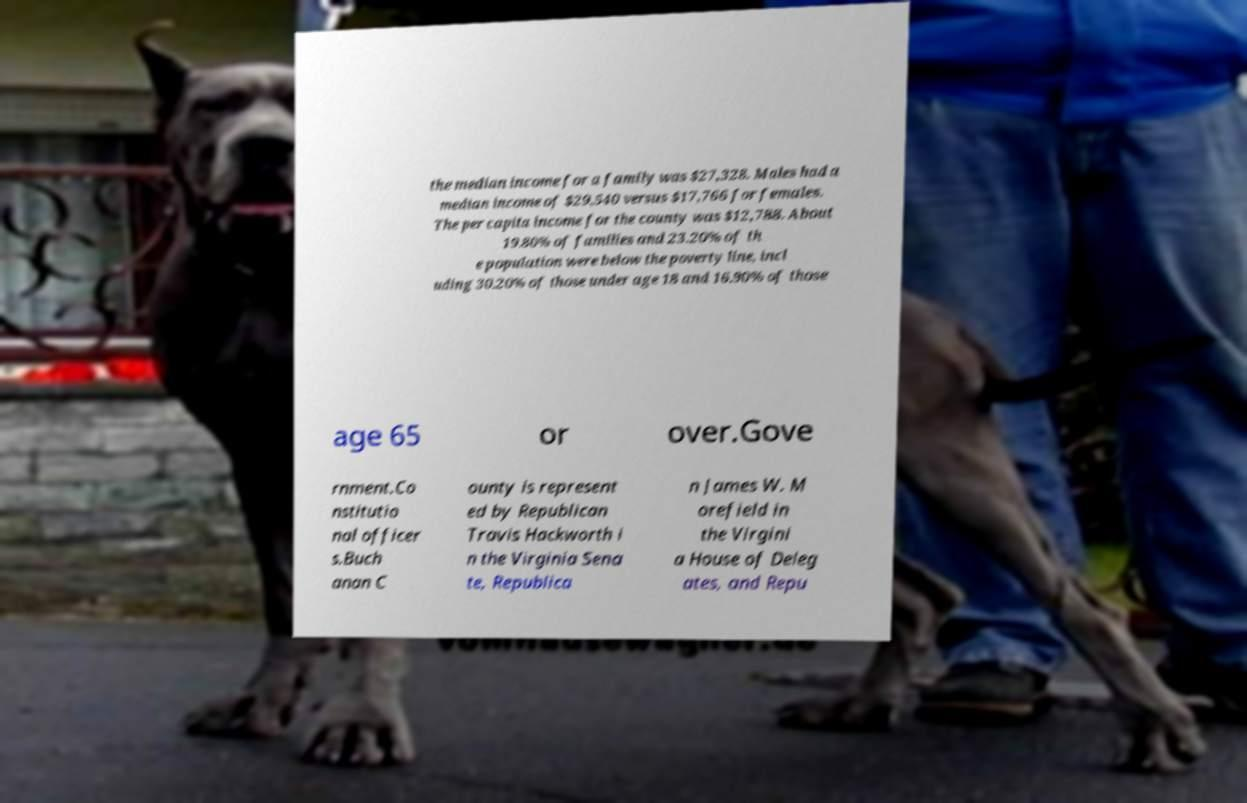Can you read and provide the text displayed in the image?This photo seems to have some interesting text. Can you extract and type it out for me? the median income for a family was $27,328. Males had a median income of $29,540 versus $17,766 for females. The per capita income for the county was $12,788. About 19.80% of families and 23.20% of th e population were below the poverty line, incl uding 30.20% of those under age 18 and 16.90% of those age 65 or over.Gove rnment.Co nstitutio nal officer s.Buch anan C ounty is represent ed by Republican Travis Hackworth i n the Virginia Sena te, Republica n James W. M orefield in the Virgini a House of Deleg ates, and Repu 